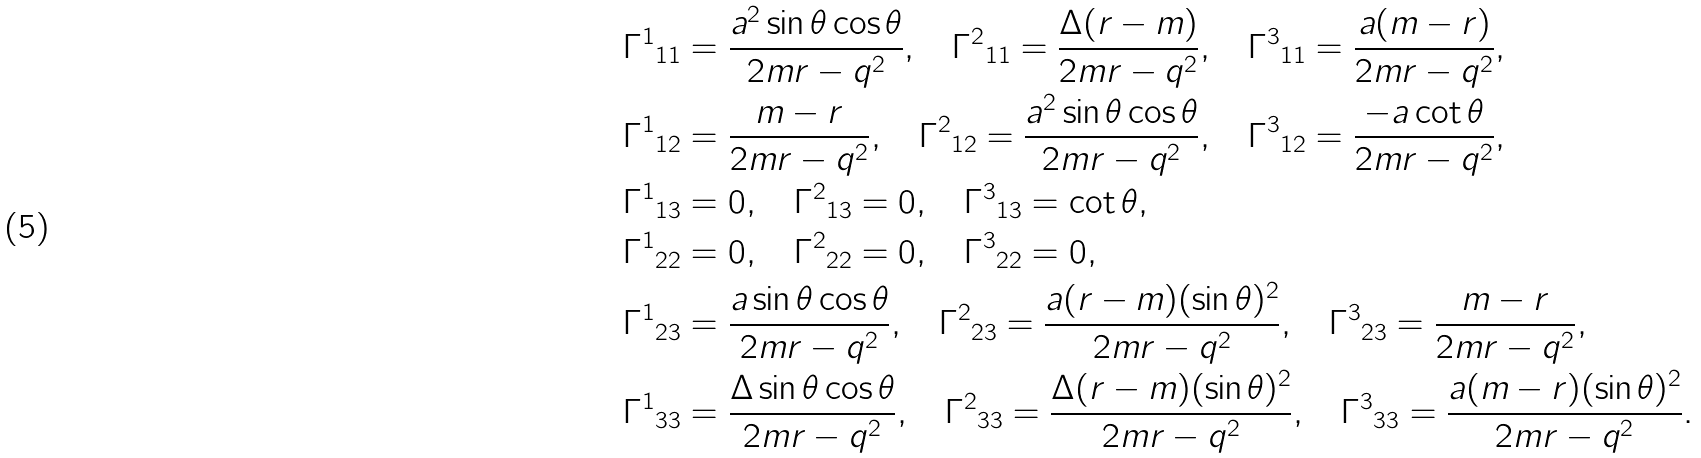Convert formula to latex. <formula><loc_0><loc_0><loc_500><loc_500>& { \Gamma ^ { 1 } } _ { 1 1 } = \frac { a ^ { 2 } \sin \theta \cos \theta } { 2 m r - q ^ { 2 } } , \quad { \Gamma ^ { 2 } } _ { 1 1 } = \frac { \Delta ( r - m ) } { 2 m r - q ^ { 2 } } , \quad { \Gamma ^ { 3 } } _ { 1 1 } = \frac { a ( m - r ) } { 2 m r - q ^ { 2 } } , \\ & { \Gamma ^ { 1 } } _ { 1 2 } = \frac { m - r } { 2 m r - q ^ { 2 } } , \quad { \Gamma ^ { 2 } } _ { 1 2 } = \frac { a ^ { 2 } \sin \theta \cos \theta } { 2 m r - q ^ { 2 } } , \quad { \Gamma ^ { 3 } } _ { 1 2 } = \frac { - a \cot \theta } { 2 m r - q ^ { 2 } } , \\ & { \Gamma ^ { 1 } } _ { 1 3 } = 0 , \quad { \Gamma ^ { 2 } } _ { 1 3 } = 0 , \quad { \Gamma ^ { 3 } } _ { 1 3 } = \cot \theta , \\ & { \Gamma ^ { 1 } } _ { 2 2 } = 0 , \quad { \Gamma ^ { 2 } } _ { 2 2 } = 0 , \quad { \Gamma ^ { 3 } } _ { 2 2 } = 0 , \\ & { \Gamma ^ { 1 } } _ { 2 3 } = \frac { a \sin \theta \cos \theta } { 2 m r - q ^ { 2 } } , \quad { \Gamma ^ { 2 } } _ { 2 3 } = \frac { a ( r - m ) ( \sin \theta ) ^ { 2 } } { 2 m r - q ^ { 2 } } , \quad { \Gamma ^ { 3 } } _ { 2 3 } = \frac { m - r } { 2 m r - q ^ { 2 } } , \\ & { \Gamma ^ { 1 } } _ { 3 3 } = \frac { \Delta \sin \theta \cos \theta } { 2 m r - q ^ { 2 } } , \quad { \Gamma ^ { 2 } } _ { 3 3 } = \frac { \Delta ( r - m ) ( \sin \theta ) ^ { 2 } } { 2 m r - q ^ { 2 } } , \quad { \Gamma ^ { 3 } } _ { 3 3 } = \frac { a ( m - r ) ( \sin \theta ) ^ { 2 } } { 2 m r - q ^ { 2 } } .</formula> 